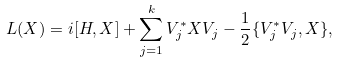<formula> <loc_0><loc_0><loc_500><loc_500>L ( X ) = i [ H , X ] + \sum _ { j = 1 } ^ { k } V _ { j } ^ { * } X V _ { j } - \frac { 1 } { 2 } \{ V _ { j } ^ { * } V _ { j } , X \} ,</formula> 